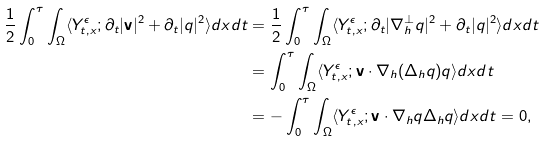<formula> <loc_0><loc_0><loc_500><loc_500>\frac { 1 } { 2 } \int ^ { \tau } _ { 0 } \int _ { \Omega } \langle Y ^ { \epsilon } _ { t , x } ; \partial _ { t } | \mathbf v | ^ { 2 } + \partial _ { t } | q | ^ { 2 } \rangle d x d t & = \frac { 1 } { 2 } \int ^ { \tau } _ { 0 } \int _ { \Omega } \langle Y ^ { \epsilon } _ { t , x } ; \partial _ { t } | \nabla _ { h } ^ { \perp } q | ^ { 2 } + \partial _ { t } | q | ^ { 2 } \rangle d x d t \\ & = \int ^ { \tau } _ { 0 } \int _ { \Omega } \langle Y ^ { \epsilon } _ { t , x } ; \mathbf v \cdot \nabla _ { h } ( \Delta _ { h } q ) q \rangle d x d t \\ & = - \int ^ { \tau } _ { 0 } \int _ { \Omega } \langle Y ^ { \epsilon } _ { t , x } ; \mathbf v \cdot \nabla _ { h } q \Delta _ { h } q \rangle d x d t = 0 ,</formula> 